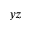<formula> <loc_0><loc_0><loc_500><loc_500>y z</formula> 